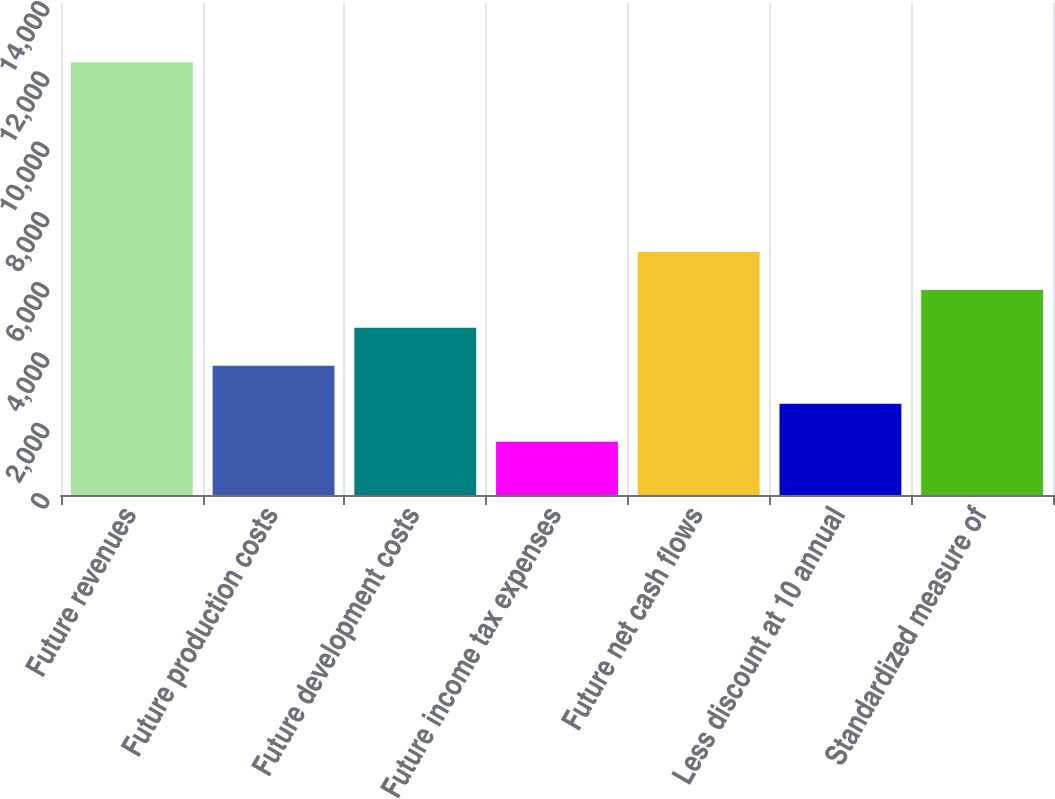<chart> <loc_0><loc_0><loc_500><loc_500><bar_chart><fcel>Future revenues<fcel>Future production costs<fcel>Future development costs<fcel>Future income tax expenses<fcel>Future net cash flows<fcel>Less discount at 10 annual<fcel>Standardized measure of<nl><fcel>12315<fcel>3676.6<fcel>4756.4<fcel>1517<fcel>6916<fcel>2596.8<fcel>5836.2<nl></chart> 